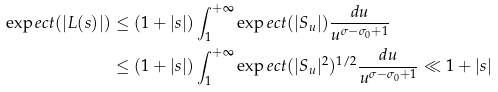Convert formula to latex. <formula><loc_0><loc_0><loc_500><loc_500>\exp e c t ( | L ( s ) | ) & \leq ( 1 + | s | ) \int _ { 1 } ^ { + \infty } \exp e c t ( | S _ { u } | ) \frac { d u } { u ^ { \sigma - \sigma _ { 0 } + 1 } } \\ & \leq ( 1 + | s | ) \int _ { 1 } ^ { + \infty } \exp e c t ( | S _ { u } | ^ { 2 } ) ^ { 1 / 2 } \frac { d u } { u ^ { \sigma - \sigma _ { 0 } + 1 } } \ll 1 + | s |</formula> 